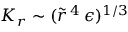Convert formula to latex. <formula><loc_0><loc_0><loc_500><loc_500>K _ { r } \sim ( \tilde { r } ^ { \, 4 } \, \epsilon ) ^ { 1 / 3 }</formula> 